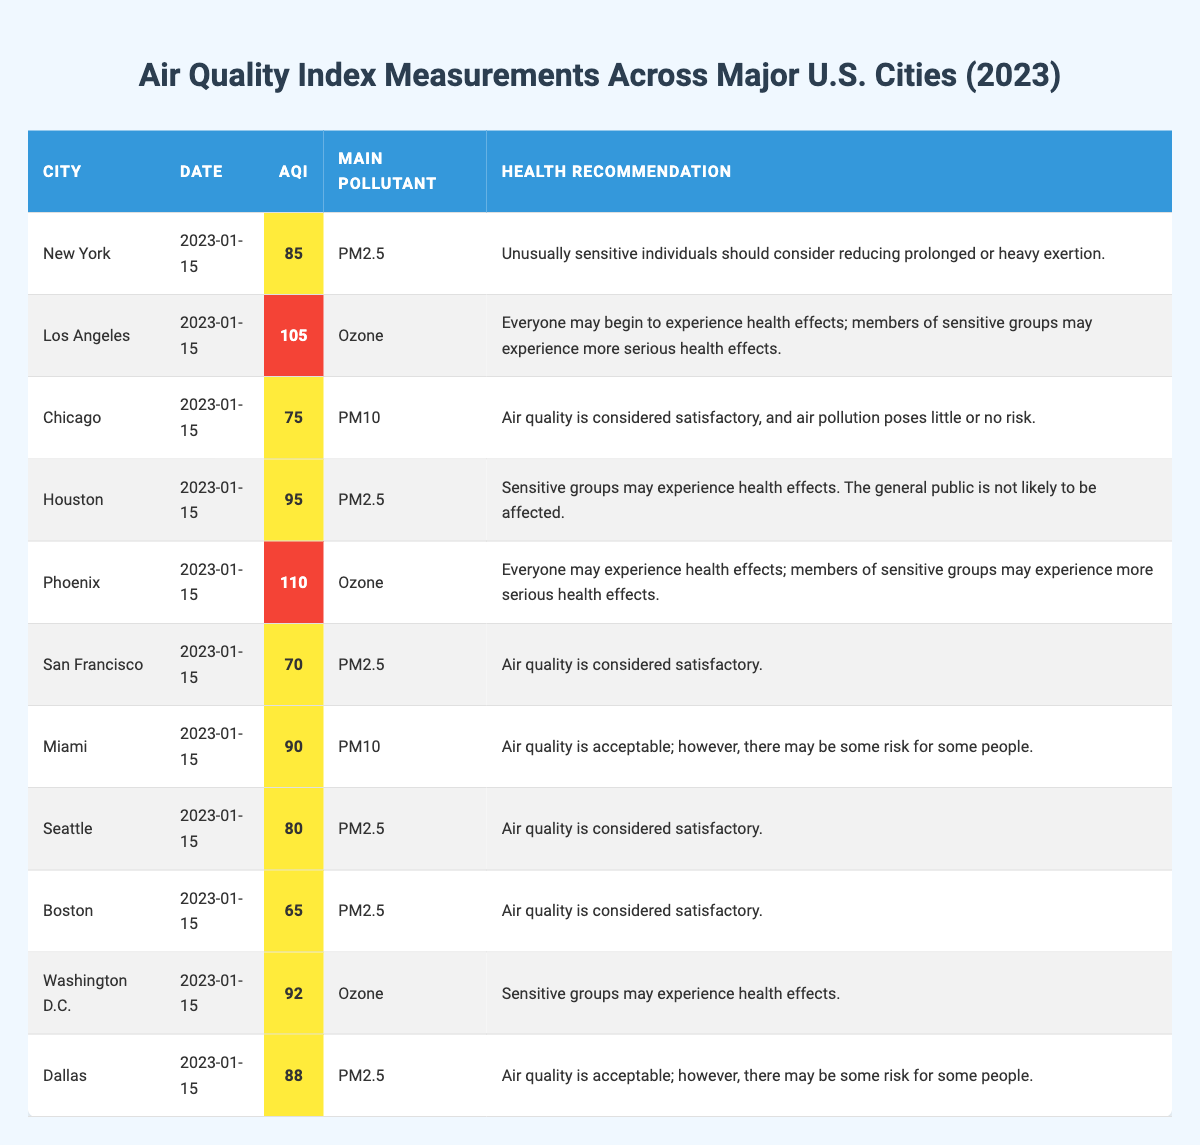What is the AQI for Los Angeles on January 15, 2023? The AQI value for Los Angeles on that date can be directly retrieved from the table, which shows it as 105.
Answer: 105 Which city has the lowest AQI on January 15, 2023? By comparing the AQI values listed in the table, the city with the lowest AQI is Boston, which has an AQI of 65.
Answer: Boston What is the main pollutant for Miami on January 15, 2023? The table specifies that the main pollutant for Miami on that date is PM10.
Answer: PM10 How many cities have an AQI value greater than 100? By counting from the table, there are two cities listed with an AQI above 100: Los Angeles (105) and Phoenix (110).
Answer: 2 What is the average AQI of all cities measured on January 15, 2023? To find the average, sum all AQI values: 85 + 105 + 75 + 95 + 110 + 70 + 90 + 80 + 65 + 92 + 88 = 1,010. The number of cities is 11, so the average is 1,010 / 11 ≈ 91.82.
Answer: 91.82 Are there any cities with an AQI in the "good" category? The table indicates that the "good" category is characterized by an AQI between 0 and 50. Since all listed cities have an AQI greater than 50, there are no cities in the "good" category.
Answer: No Which city has the highest AQI, and what is that value? The highest AQI is found by scanning the values, with Phoenix at 110 being the maximum.
Answer: Phoenix, 110 How many cities have their main pollutant identified as Ozone? By reviewing the table, the cities with Ozone as the main pollutant are Los Angeles, Phoenix, and Washington D.C., totaling three cities.
Answer: 3 Is the health recommendation for Houston indicating serious health effects? According to the table, the health recommendation for Houston indicates only that sensitive groups may experience health effects, not serious effects for the general public, making it a "no."
Answer: No What is the difference in AQI between Chicago and New York? The AQI for Chicago is 75 and for New York is 85. The difference is calculated as 85 - 75 = 10.
Answer: 10 What can be concluded about the air quality levels among these cities? By summarizing the AQI values and associated health recommendations, it can be concluded that cities like Boston and Chicago have satisfactory air quality, while Los Angeles and Phoenix show unhealthy levels, necessitating caution for sensitive individuals.
Answer: Varied levels; some satisfactory, some unhealthy 